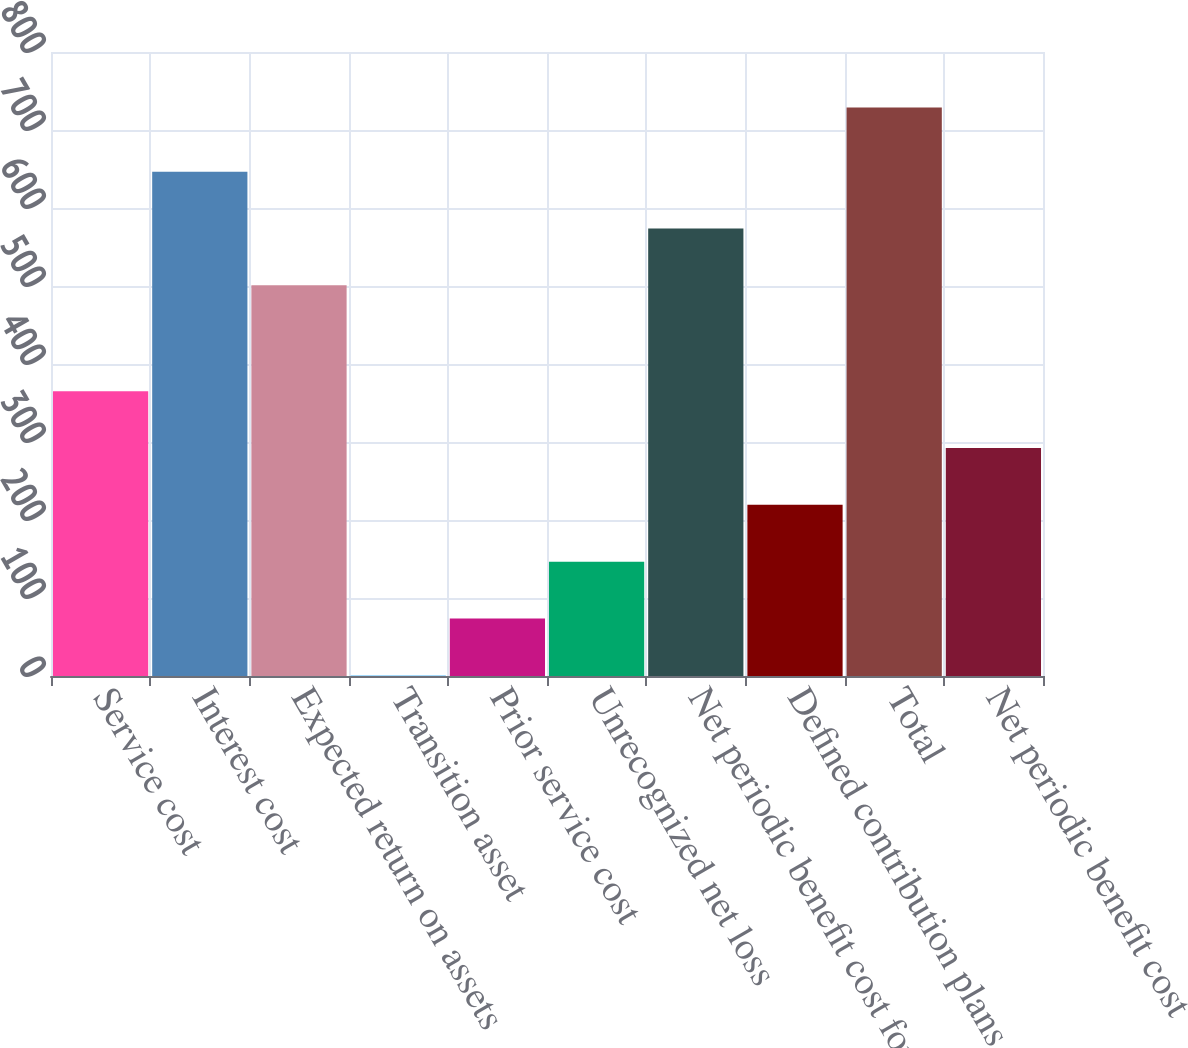Convert chart. <chart><loc_0><loc_0><loc_500><loc_500><bar_chart><fcel>Service cost<fcel>Interest cost<fcel>Expected return on assets<fcel>Transition asset<fcel>Prior service cost<fcel>Unrecognized net loss<fcel>Net periodic benefit cost for<fcel>Defined contribution plans<fcel>Total<fcel>Net periodic benefit cost<nl><fcel>365<fcel>646.6<fcel>501<fcel>1<fcel>73.8<fcel>146.6<fcel>573.8<fcel>219.4<fcel>729<fcel>292.2<nl></chart> 